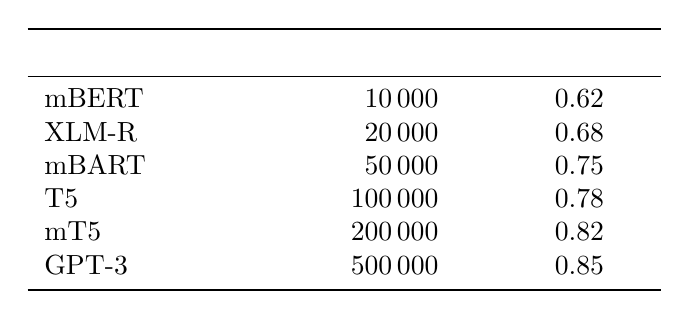What is the accuracy of the mBERT model? The accuracy for the mBERT model is listed in the table under the accuracy column, which shows 0.62.
Answer: 0.62 Which model has the highest accuracy? By examining the accuracy column in the table, GPT-3 shows the highest value of 0.85 among all the models.
Answer: GPT-3 What is the dataset size for mT5? The dataset size for mT5 can be found directly in the 'Dataset Size' column, which is 200000.
Answer: 200000 What is the average accuracy of the listed models? To find the average accuracy, sum up the accuracies of all models: (0.62 + 0.68 + 0.75 + 0.78 + 0.82 + 0.85) = 4.50. Then divide by the number of models (6), which gives 4.50 / 6 = 0.75.
Answer: 0.75 Is the accuracy of XLM-R greater than that of mBART? XLM-R has an accuracy of 0.68 while mBART has an accuracy of 0.75. Comparing these values shows that 0.68 is less than 0.75, so the statement is false.
Answer: No What is the increase in accuracy from mBERT to T5? The accuracy of mBERT is 0.62 and that of T5 is 0.78. The increase in accuracy can be calculated by subtracting: 0.78 - 0.62 = 0.16.
Answer: 0.16 Does the dataset size for GPT-3 exceed 400000? The dataset size for GPT-3 is listed as 500000, which is greater than 400000, making this statement true.
Answer: Yes How many language models have an accuracy greater than 0.75? Reviewing the accuracy column, mBART (0.75), T5 (0.78), mT5 (0.82), and GPT-3 (0.85) have accuracies greater than 0.75, resulting in a total of 4 models.
Answer: 4 What is the difference in dataset size between GPT-3 and mT5? The dataset size for GPT-3 is 500000 and for mT5 is 200000. The difference can be calculated by subtracting: 500000 - 200000 = 300000.
Answer: 300000 